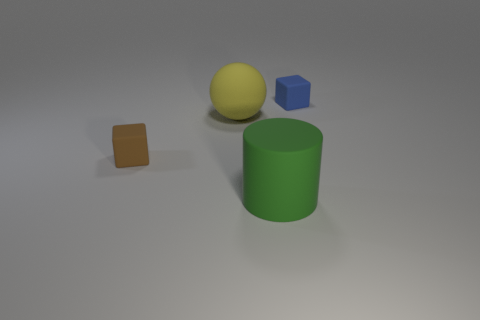There is a rubber block that is in front of the tiny blue thing; how many spheres are on the right side of it?
Offer a very short reply. 1. What number of rubber objects are to the right of the brown rubber block and in front of the small blue cube?
Provide a short and direct response. 2. How many other things are made of the same material as the cylinder?
Provide a succinct answer. 3. What color is the cube that is on the left side of the small rubber block that is right of the large green rubber cylinder?
Your response must be concise. Brown. There is a small cube to the right of the brown object; is its color the same as the cylinder?
Ensure brevity in your answer.  No. Does the blue rubber block have the same size as the brown cube?
Your response must be concise. Yes. What shape is the other object that is the same size as the yellow rubber object?
Ensure brevity in your answer.  Cylinder. Is the size of the rubber block that is to the right of the brown rubber thing the same as the green rubber object?
Give a very brief answer. No. There is a object that is the same size as the brown cube; what material is it?
Ensure brevity in your answer.  Rubber. Are there any small matte cubes that are left of the small cube that is to the right of the block to the left of the green cylinder?
Provide a short and direct response. Yes. 